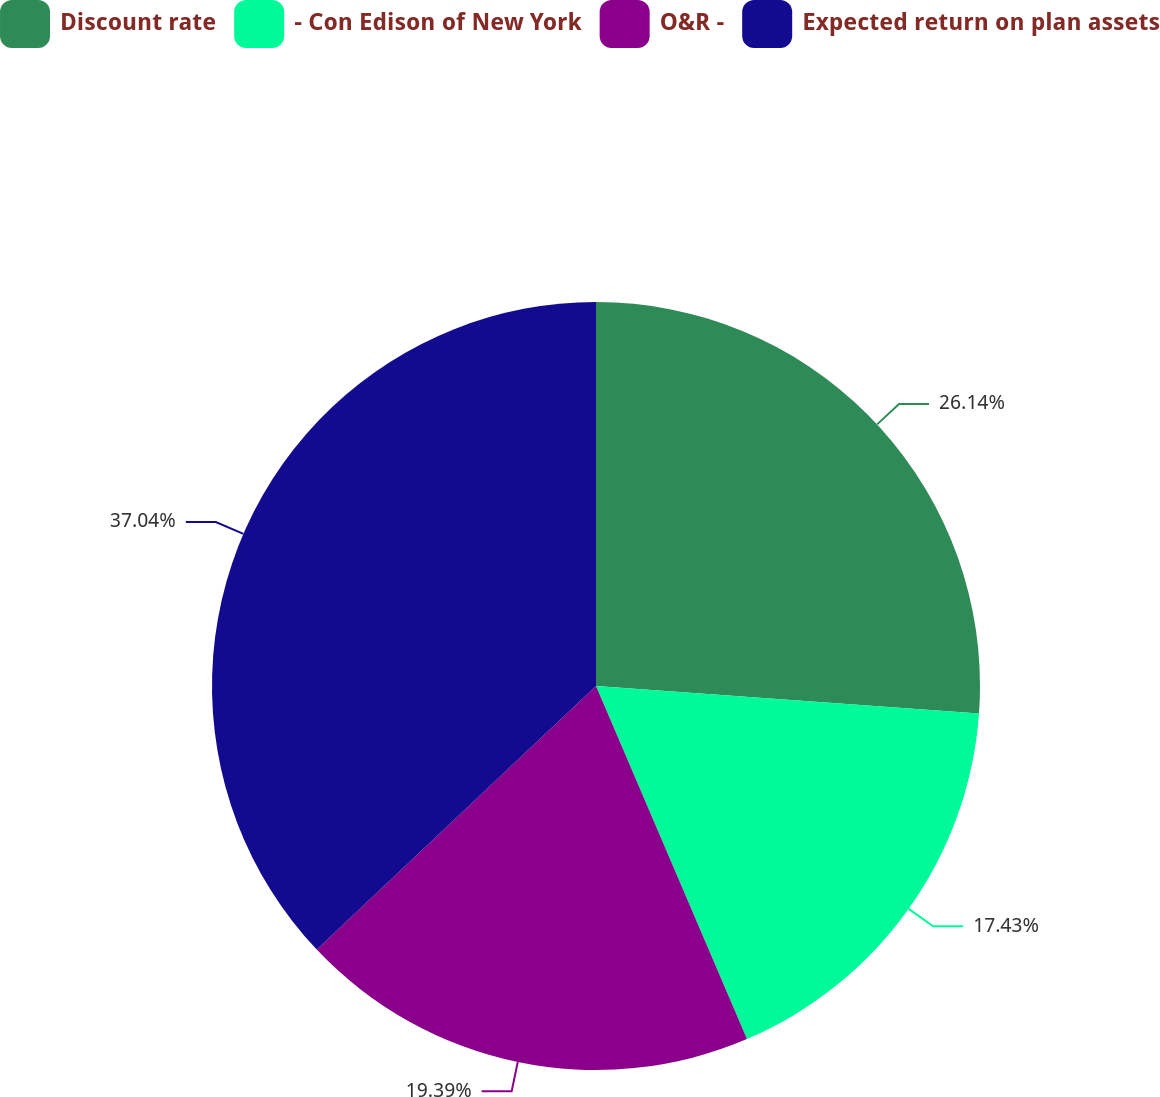Convert chart to OTSL. <chart><loc_0><loc_0><loc_500><loc_500><pie_chart><fcel>Discount rate<fcel>- Con Edison of New York<fcel>O&R -<fcel>Expected return on plan assets<nl><fcel>26.14%<fcel>17.43%<fcel>19.39%<fcel>37.04%<nl></chart> 